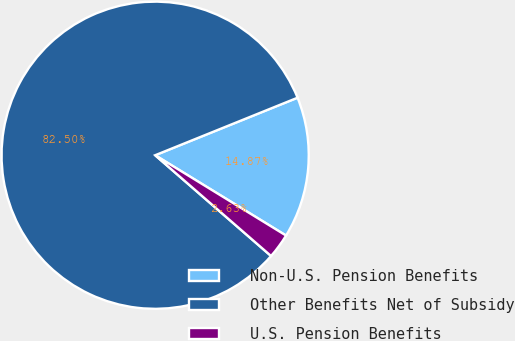Convert chart. <chart><loc_0><loc_0><loc_500><loc_500><pie_chart><fcel>Non-U.S. Pension Benefits<fcel>Other Benefits Net of Subsidy<fcel>U.S. Pension Benefits<nl><fcel>14.87%<fcel>82.5%<fcel>2.63%<nl></chart> 